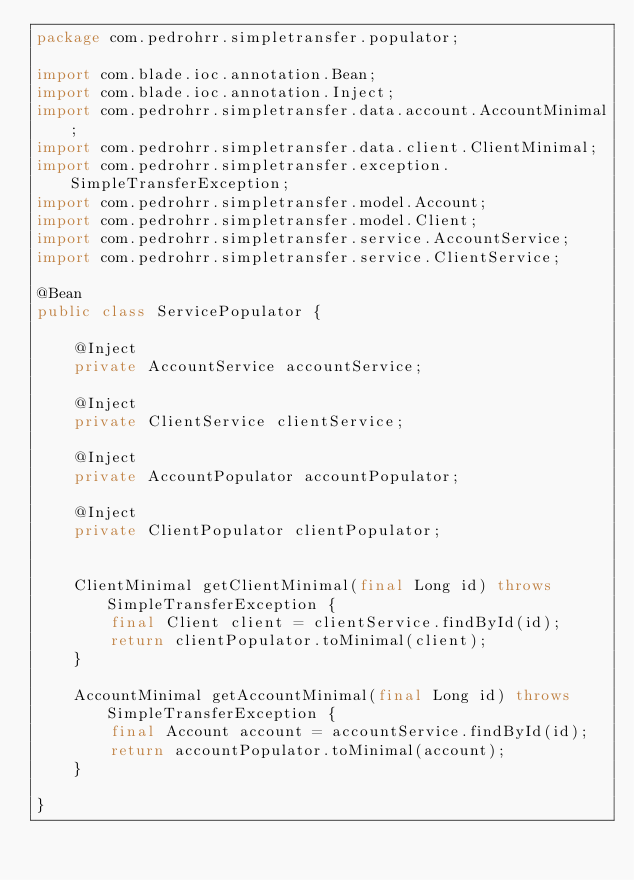Convert code to text. <code><loc_0><loc_0><loc_500><loc_500><_Java_>package com.pedrohrr.simpletransfer.populator;

import com.blade.ioc.annotation.Bean;
import com.blade.ioc.annotation.Inject;
import com.pedrohrr.simpletransfer.data.account.AccountMinimal;
import com.pedrohrr.simpletransfer.data.client.ClientMinimal;
import com.pedrohrr.simpletransfer.exception.SimpleTransferException;
import com.pedrohrr.simpletransfer.model.Account;
import com.pedrohrr.simpletransfer.model.Client;
import com.pedrohrr.simpletransfer.service.AccountService;
import com.pedrohrr.simpletransfer.service.ClientService;

@Bean
public class ServicePopulator {

    @Inject
    private AccountService accountService;

    @Inject
    private ClientService clientService;

    @Inject
    private AccountPopulator accountPopulator;

    @Inject
    private ClientPopulator clientPopulator;


    ClientMinimal getClientMinimal(final Long id) throws SimpleTransferException {
        final Client client = clientService.findById(id);
        return clientPopulator.toMinimal(client);
    }

    AccountMinimal getAccountMinimal(final Long id) throws SimpleTransferException {
        final Account account = accountService.findById(id);
        return accountPopulator.toMinimal(account);
    }

}
</code> 